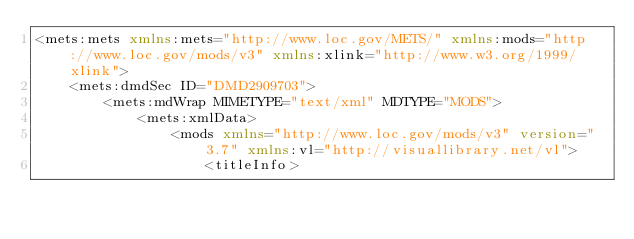Convert code to text. <code><loc_0><loc_0><loc_500><loc_500><_XML_><mets:mets xmlns:mets="http://www.loc.gov/METS/" xmlns:mods="http://www.loc.gov/mods/v3" xmlns:xlink="http://www.w3.org/1999/xlink">
    <mets:dmdSec ID="DMD2909703">
        <mets:mdWrap MIMETYPE="text/xml" MDTYPE="MODS">
            <mets:xmlData>
                <mods xmlns="http://www.loc.gov/mods/v3" version="3.7" xmlns:vl="http://visuallibrary.net/vl">
                    <titleInfo></code> 